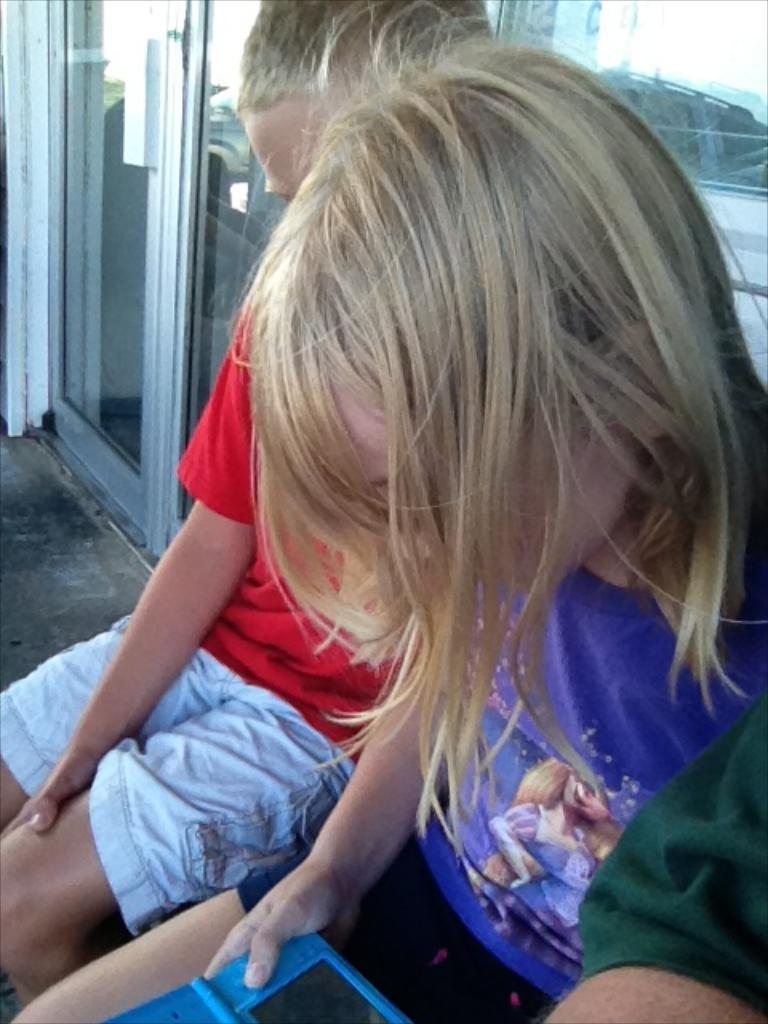Who or what can be seen in the image? There are people in the image. Can you describe the girl in the image? The girl is holding an object in her hand. What can be seen in the background of the image? There is a building with doors in the background of the image. What type of stitch is being used to sew the bricks together in the wilderness? There is no mention of stitching, bricks, or wilderness in the image. 